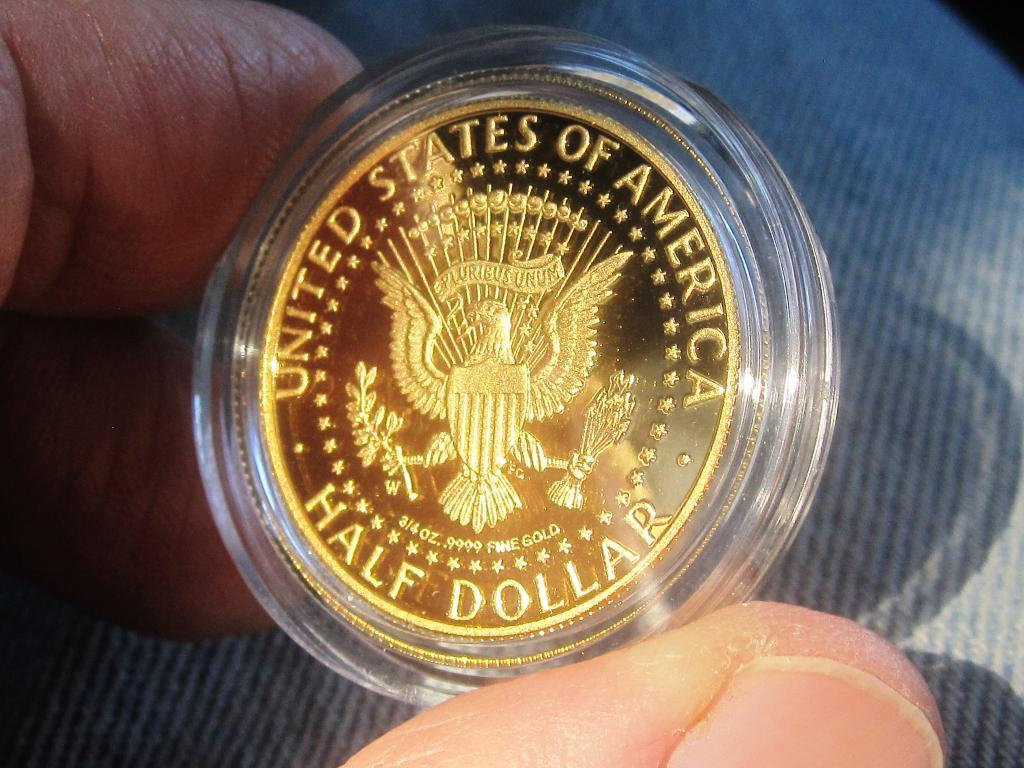<image>
Write a terse but informative summary of the picture. A coin that says United States of America Half Dollar. 